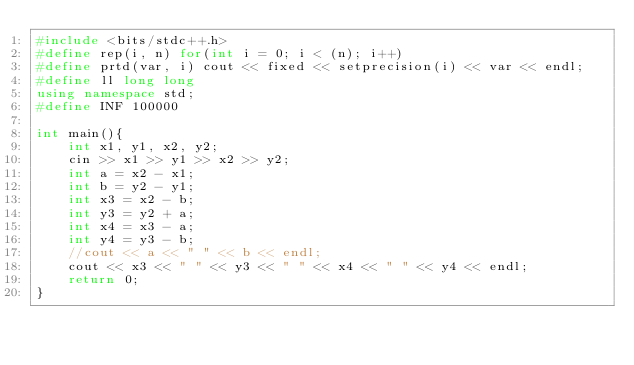<code> <loc_0><loc_0><loc_500><loc_500><_C++_>#include <bits/stdc++.h>
#define rep(i, n) for(int i = 0; i < (n); i++)
#define prtd(var, i) cout << fixed << setprecision(i) << var << endl;
#define ll long long
using namespace std;
#define INF 100000

int main(){
    int x1, y1, x2, y2;
    cin >> x1 >> y1 >> x2 >> y2;
    int a = x2 - x1;
    int b = y2 - y1;
    int x3 = x2 - b;
    int y3 = y2 + a; 
    int x4 = x3 - a; 
    int y4 = y3 - b;
    //cout << a << " " << b << endl;
    cout << x3 << " " << y3 << " " << x4 << " " << y4 << endl;
    return 0;
}
</code> 